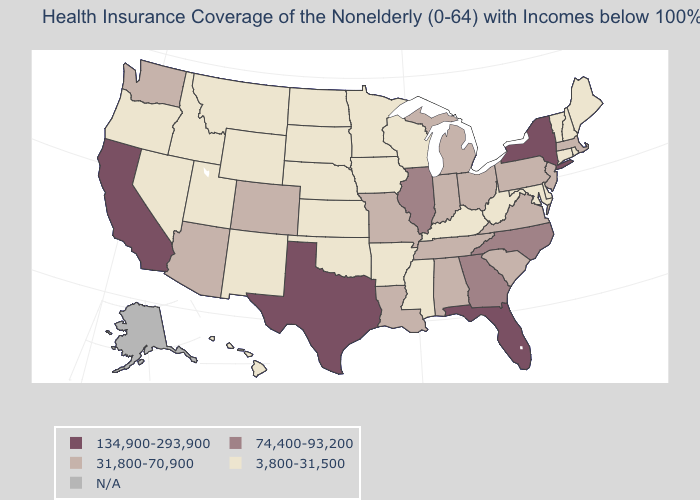What is the highest value in the West ?
Short answer required. 134,900-293,900. Does the map have missing data?
Keep it brief. Yes. Which states have the lowest value in the USA?
Short answer required. Arkansas, Connecticut, Delaware, Hawaii, Idaho, Iowa, Kansas, Kentucky, Maine, Maryland, Minnesota, Mississippi, Montana, Nebraska, Nevada, New Hampshire, New Mexico, North Dakota, Oklahoma, Oregon, Rhode Island, South Dakota, Utah, Vermont, West Virginia, Wisconsin, Wyoming. What is the highest value in the USA?
Give a very brief answer. 134,900-293,900. Is the legend a continuous bar?
Be succinct. No. Name the states that have a value in the range 74,400-93,200?
Quick response, please. Georgia, Illinois, North Carolina. Which states have the lowest value in the Northeast?
Keep it brief. Connecticut, Maine, New Hampshire, Rhode Island, Vermont. How many symbols are there in the legend?
Be succinct. 5. What is the lowest value in the Northeast?
Be succinct. 3,800-31,500. Which states hav the highest value in the South?
Keep it brief. Florida, Texas. Which states hav the highest value in the Northeast?
Keep it brief. New York. What is the value of Kentucky?
Answer briefly. 3,800-31,500. Name the states that have a value in the range N/A?
Quick response, please. Alaska. 